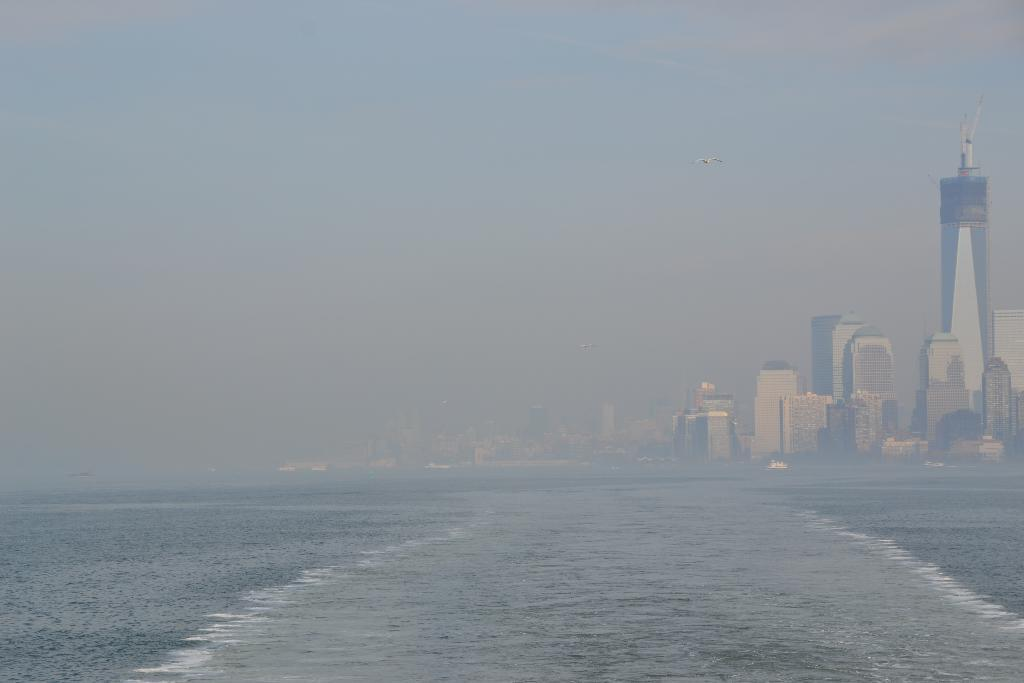What is the main feature of the image? There is an ocean in the image. What can be seen in the distance behind the ocean? There are buildings in the background of the image. How would you describe the weather in the image? The sky is cloudy in the image. What is flying in the sky in the image? There is an object flying in the sky, which is white in color. How many children are playing in the shade of the buildings in the image? There are no children present in the image, and there is no shade provided by the buildings. 